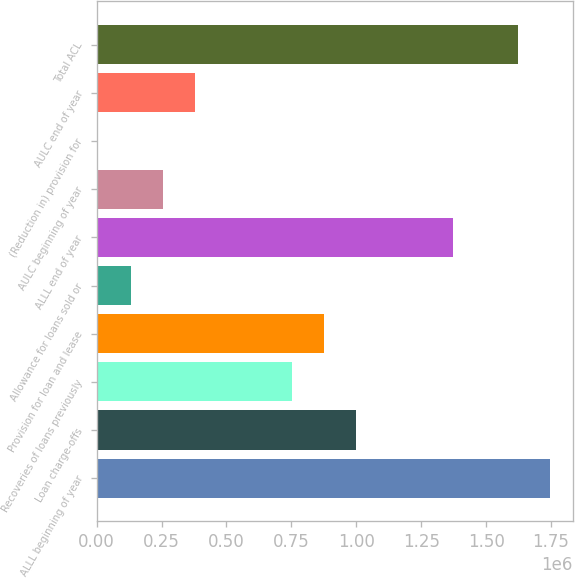Convert chart to OTSL. <chart><loc_0><loc_0><loc_500><loc_500><bar_chart><fcel>ALLL beginning of year<fcel>Loan charge-offs<fcel>Recoveries of loans previously<fcel>Provision for loan and lease<fcel>Allowance for loans sold or<fcel>ALLL end of year<fcel>AULC beginning of year<fcel>(Reduction in) provision for<fcel>AULC end of year<fcel>Total ACL<nl><fcel>1.74608e+06<fcel>1.00047e+06<fcel>751936<fcel>876204<fcel>130597<fcel>1.37328e+06<fcel>254865<fcel>6329<fcel>379133<fcel>1.62181e+06<nl></chart> 